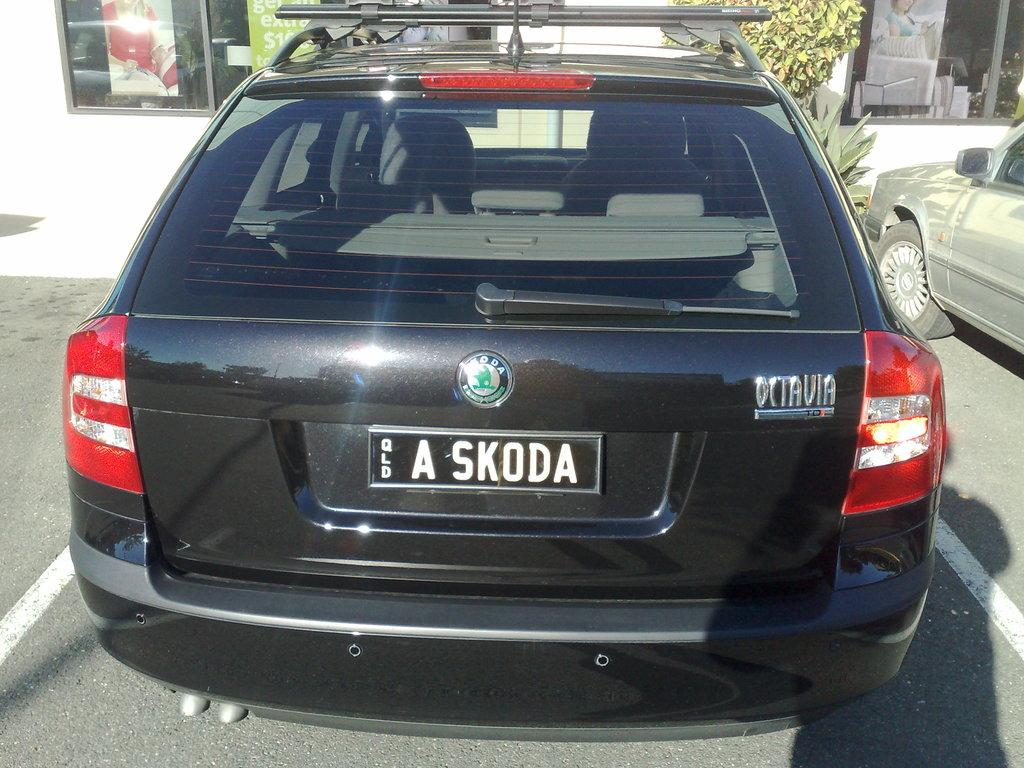<image>
Write a terse but informative summary of the picture. A black car with license plate number a skoda on it 